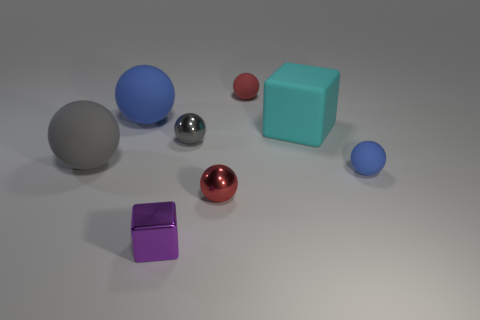Subtract 3 spheres. How many spheres are left? 3 Subtract all tiny metal balls. How many balls are left? 4 Subtract all red balls. How many balls are left? 4 Subtract all yellow spheres. Subtract all brown blocks. How many spheres are left? 6 Add 2 cyan matte objects. How many objects exist? 10 Subtract all cubes. How many objects are left? 6 Add 6 small purple metal objects. How many small purple metal objects exist? 7 Subtract 0 blue blocks. How many objects are left? 8 Subtract all small metal blocks. Subtract all tiny blue matte objects. How many objects are left? 6 Add 6 blue things. How many blue things are left? 8 